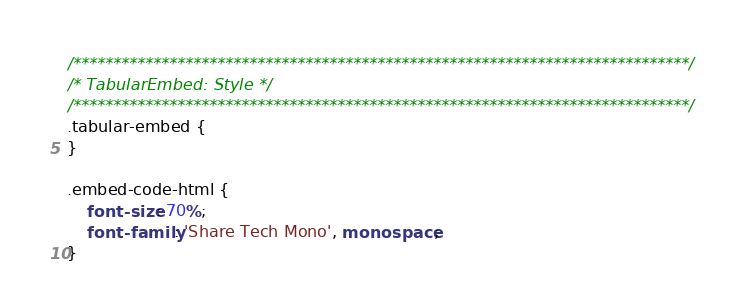<code> <loc_0><loc_0><loc_500><loc_500><_CSS_>/*****************************************************************************/
/* TabularEmbed: Style */
/*****************************************************************************/
.tabular-embed {
}

.embed-code-html {
    font-size: 70%;
    font-family: 'Share Tech Mono', monospace;
}
</code> 